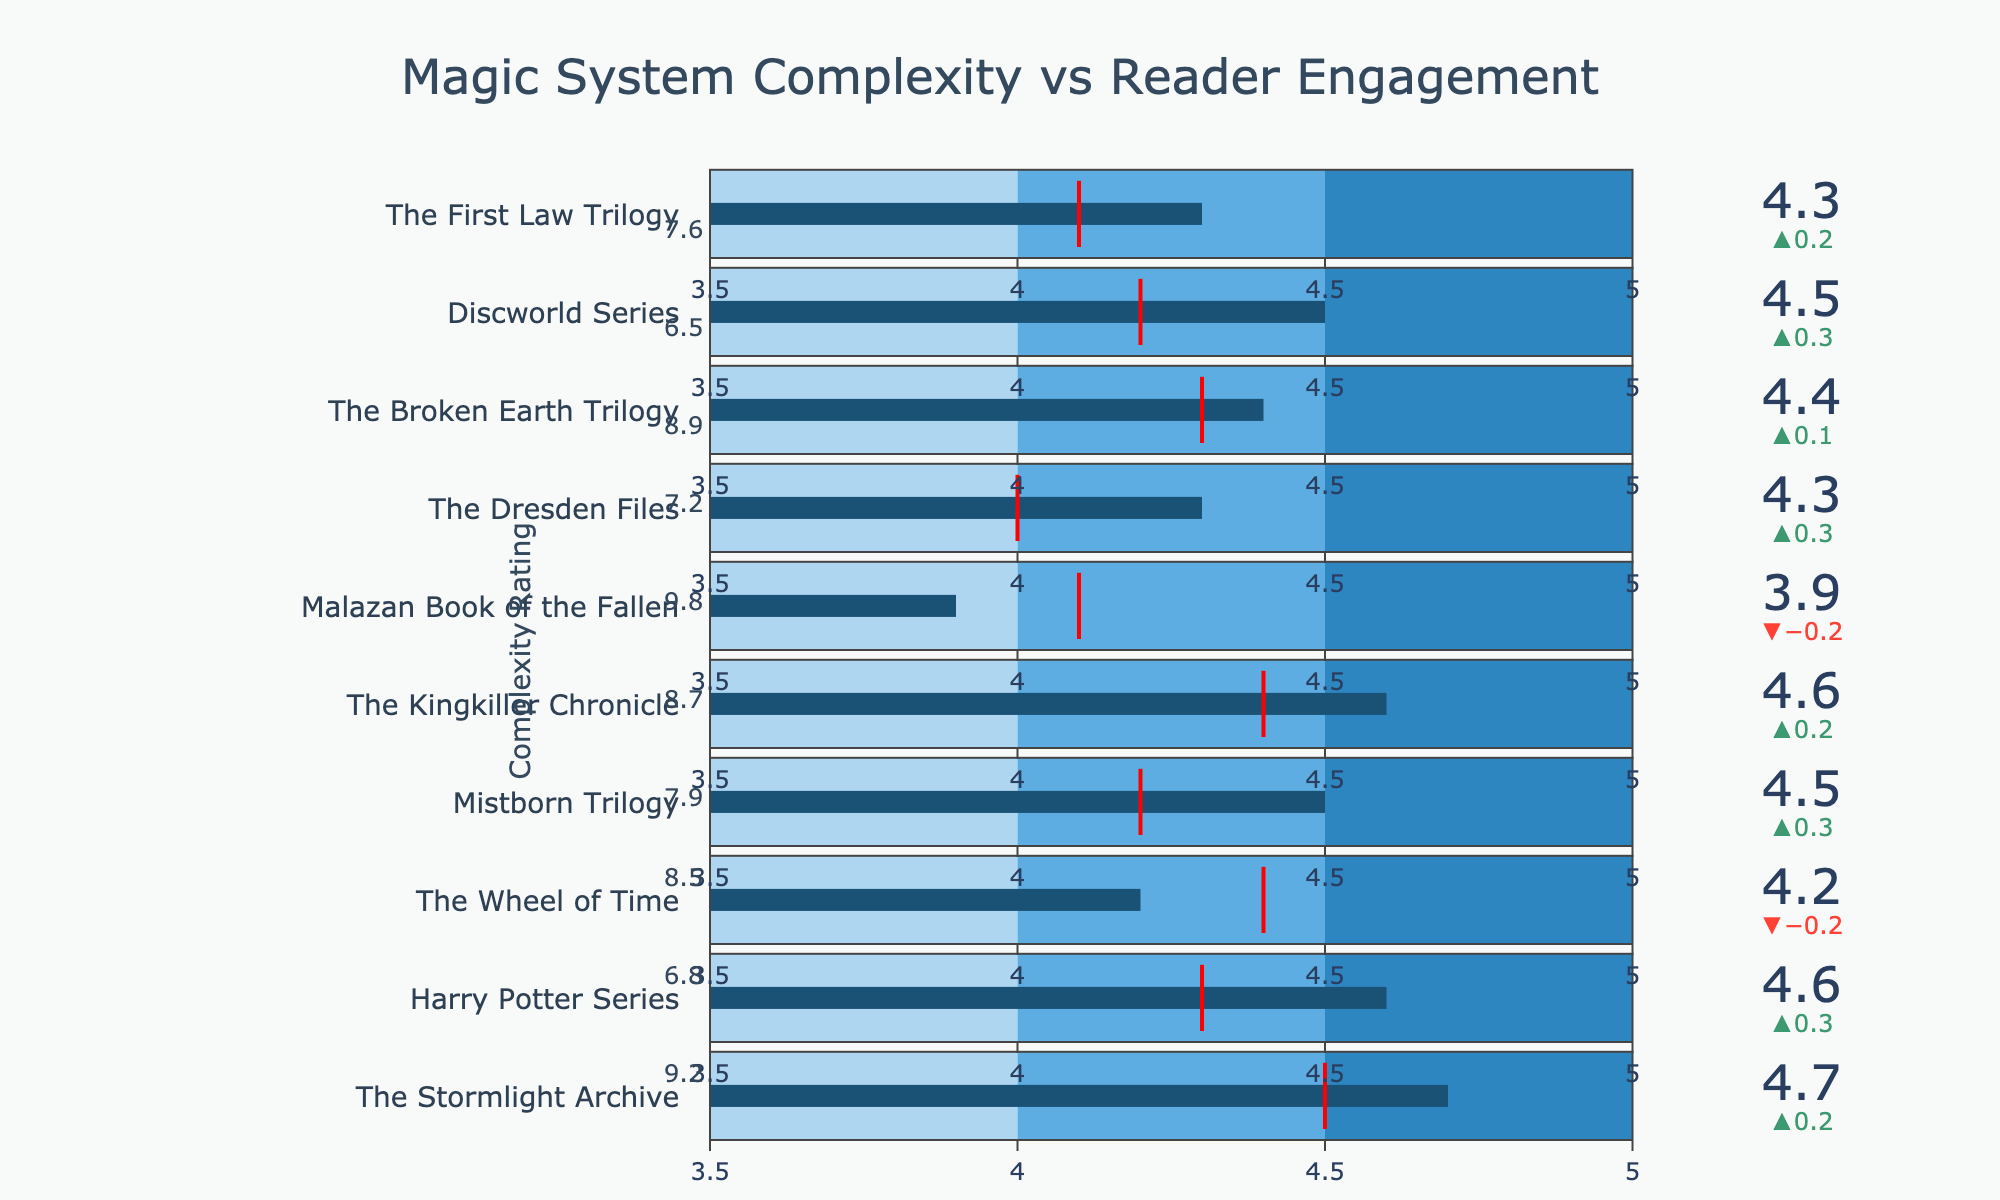What is the title of the figure? The title is displayed at the top of the figure.
Answer: Magic System Complexity vs Reader Engagement Which book has the highest complexity rating? Look for the book with the highest value in the "Complexity Rating" column shown next to each bullet chart.
Answer: Malazan Book of the Fallen How many books have an average rating above their target rating? Compare the "Average Rating" to the "Target Rating" for each book to count how many exceed.
Answer: 6 Which series has the lowest average rating, and what is it? Identify the book with the lowest value in the "Average Rating" column.
Answer: Malazan Book of the Fallen with 3.9 Which book shows the largest positive difference between its average rating and target rating? Calculate the difference for each book (Average Rating - Target Rating) and find the maximum positive value.
Answer: The Stormlight Archive What is the relationship between complexity rating and average rating for The Broken Earth Trilogy? Examine the "Complexity Rating" and "Average Rating" of The Broken Earth Trilogy to explain any correlation or pattern.
Answer: High complexity (8.9) with high reader engagement (4.4) Which books have their ratings within the highest step color band (4.5 to 5.0)? Identify books whose "Average Rating" falls within the 4.5 to 5.0 range indicated by the darkest color band.
Answer: The Stormlight Archive, Harry Potter Series, Discworld Series On average, does higher complexity correlate with higher reader engagement across these books? Look at the general trend in the data by comparing complexity ratings to reader engagements.
Answer: No clear trend; some high complexity books have high engagement, others don't 